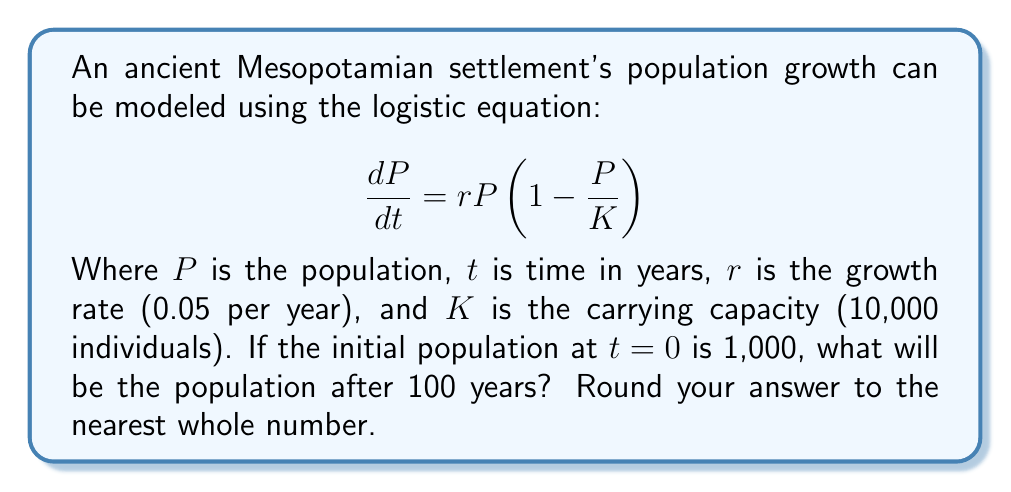Can you solve this math problem? To solve this problem, we need to use the solution to the logistic equation:

1) The general solution to the logistic equation is:

   $$P(t) = \frac{K}{1 + (\frac{K}{P_0} - 1)e^{-rt}}$$

   Where $P_0$ is the initial population.

2) We're given:
   $K = 10,000$
   $r = 0.05$
   $P_0 = 1,000$
   $t = 100$

3) Let's substitute these values into the equation:

   $$P(100) = \frac{10,000}{1 + (\frac{10,000}{1,000} - 1)e^{-0.05(100)}}$$

4) Simplify:
   $$P(100) = \frac{10,000}{1 + 9e^{-5}}$$

5) Calculate $e^{-5}$:
   $$e^{-5} \approx 0.00674$$

6) Substitute this value:
   $$P(100) = \frac{10,000}{1 + 9(0.00674)} = \frac{10,000}{1.06066}$$

7) Calculate the final result:
   $$P(100) \approx 9,428.96$$

8) Rounding to the nearest whole number:
   $$P(100) \approx 9,429$$
Answer: 9,429 